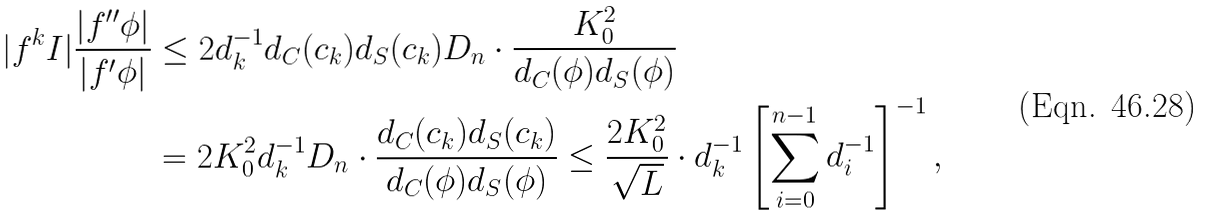Convert formula to latex. <formula><loc_0><loc_0><loc_500><loc_500>| f ^ { k } I | \frac { | f ^ { \prime \prime } \phi | } { | f ^ { \prime } \phi | } & \leq 2 d _ { k } ^ { - 1 } d _ { C } ( c _ { k } ) d _ { S } ( c _ { k } ) D _ { n } \cdot \frac { K _ { 0 } ^ { 2 } } { d _ { C } ( \phi ) d _ { S } ( \phi ) } \\ & = 2 K _ { 0 } ^ { 2 } d _ { k } ^ { - 1 } D _ { n } \cdot \frac { d _ { C } ( c _ { k } ) d _ { S } ( c _ { k } ) } { d _ { C } ( \phi ) d _ { S } ( \phi ) } \leq \frac { 2 K _ { 0 } ^ { 2 } } { \sqrt { L } } \cdot d _ { k } ^ { - 1 } \left [ \sum _ { i = 0 } ^ { n - 1 } d _ { i } ^ { - 1 } \right ] ^ { - 1 } ,</formula> 